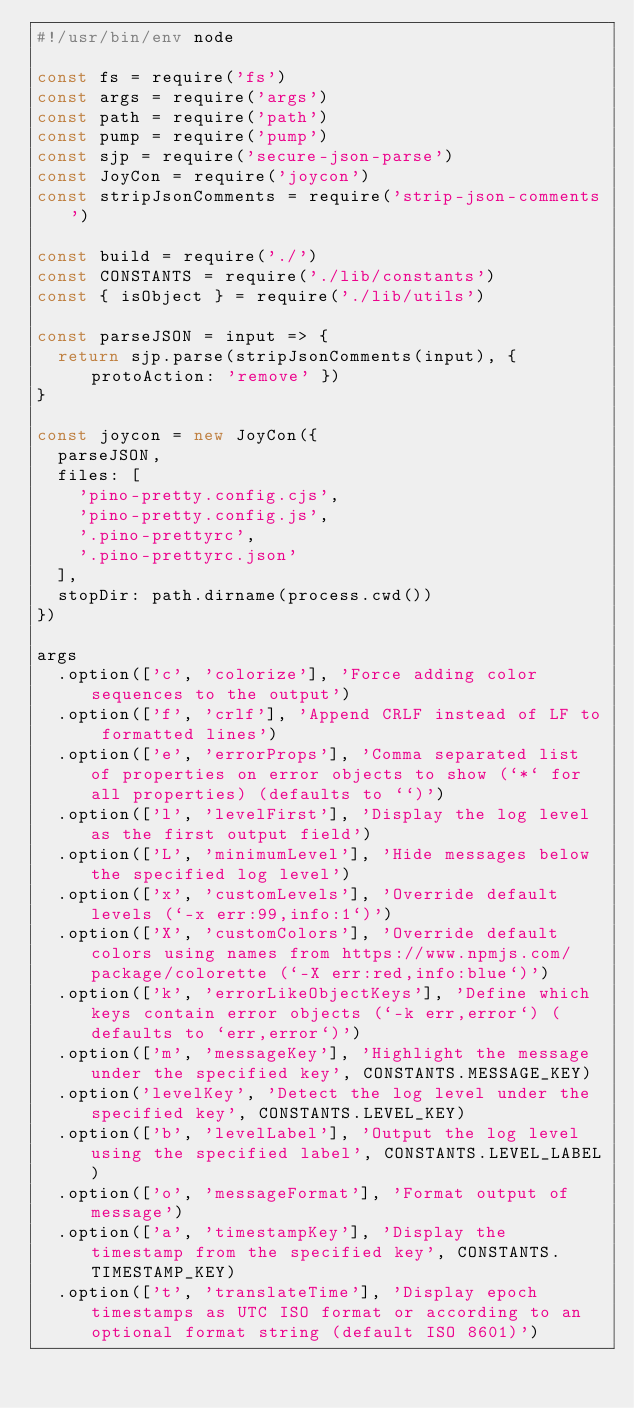<code> <loc_0><loc_0><loc_500><loc_500><_JavaScript_>#!/usr/bin/env node

const fs = require('fs')
const args = require('args')
const path = require('path')
const pump = require('pump')
const sjp = require('secure-json-parse')
const JoyCon = require('joycon')
const stripJsonComments = require('strip-json-comments')

const build = require('./')
const CONSTANTS = require('./lib/constants')
const { isObject } = require('./lib/utils')

const parseJSON = input => {
  return sjp.parse(stripJsonComments(input), { protoAction: 'remove' })
}

const joycon = new JoyCon({
  parseJSON,
  files: [
    'pino-pretty.config.cjs',
    'pino-pretty.config.js',
    '.pino-prettyrc',
    '.pino-prettyrc.json'
  ],
  stopDir: path.dirname(process.cwd())
})

args
  .option(['c', 'colorize'], 'Force adding color sequences to the output')
  .option(['f', 'crlf'], 'Append CRLF instead of LF to formatted lines')
  .option(['e', 'errorProps'], 'Comma separated list of properties on error objects to show (`*` for all properties) (defaults to ``)')
  .option(['l', 'levelFirst'], 'Display the log level as the first output field')
  .option(['L', 'minimumLevel'], 'Hide messages below the specified log level')
  .option(['x', 'customLevels'], 'Override default levels (`-x err:99,info:1`)')
  .option(['X', 'customColors'], 'Override default colors using names from https://www.npmjs.com/package/colorette (`-X err:red,info:blue`)')
  .option(['k', 'errorLikeObjectKeys'], 'Define which keys contain error objects (`-k err,error`) (defaults to `err,error`)')
  .option(['m', 'messageKey'], 'Highlight the message under the specified key', CONSTANTS.MESSAGE_KEY)
  .option('levelKey', 'Detect the log level under the specified key', CONSTANTS.LEVEL_KEY)
  .option(['b', 'levelLabel'], 'Output the log level using the specified label', CONSTANTS.LEVEL_LABEL)
  .option(['o', 'messageFormat'], 'Format output of message')
  .option(['a', 'timestampKey'], 'Display the timestamp from the specified key', CONSTANTS.TIMESTAMP_KEY)
  .option(['t', 'translateTime'], 'Display epoch timestamps as UTC ISO format or according to an optional format string (default ISO 8601)')</code> 